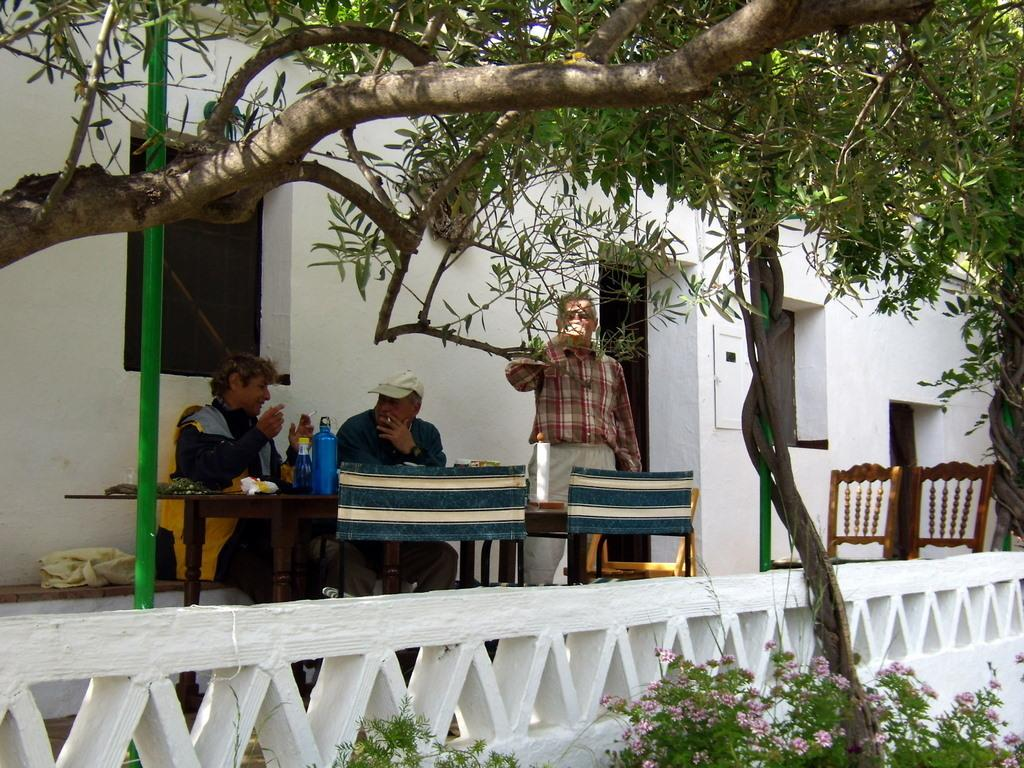How many men are in the image? There are three men in the image. What are the men doing in the image? The men are sitting on chairs. Where are the chairs located in relation to the table? The chairs are in front of a table. What type of structure can be seen in the background of the image? There is a house visible in the image. What type of vegetation is present in the image? There are trees in the image. What type of hose is being used by the owner to make a decision in the image? There is no hose or decision-making process depicted in the image. The image only shows three men sitting on chairs in front of a table, with a house and trees visible in the background. 